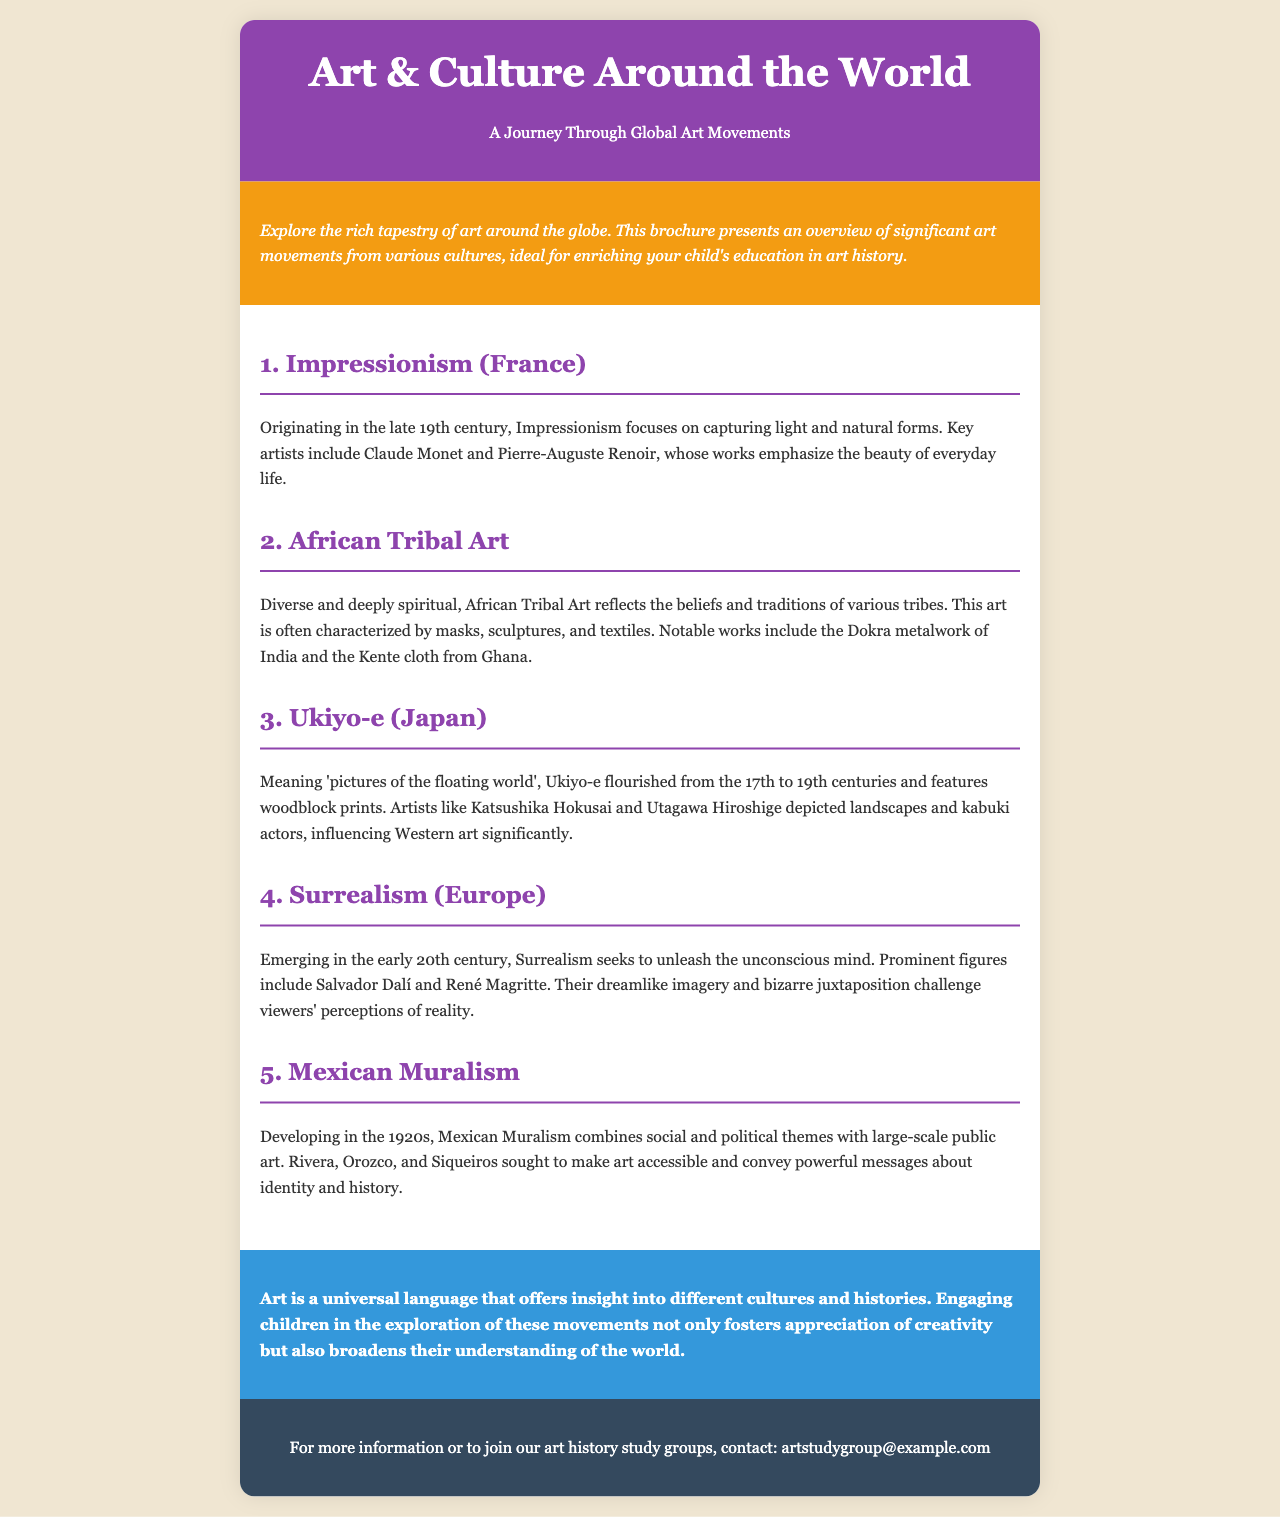What is the title of the brochure? The title of the brochure is found in the header section, stating the main theme.
Answer: Art & Culture Around the World Who is a key artist of Impressionism? This information is found in the description of the Impressionism section, highlighting notable figures.
Answer: Claude Monet Which art movement focuses on capturing light and natural forms? The statement regarding this movement is in the overview of one of the sections.
Answer: Impressionism What type of art is characterized by masks and textiles? This characteristic is specifically mentioned in the section discussing different art forms.
Answer: African Tribal Art In what century did Ukiyo-e flourish? The timeframe for Ukiyo-e's flourishing is mentioned within its specific section.
Answer: 17th to 19th centuries Who are three prominent Mexican muralists? This detail is highlighted in the description of the Mexican Muralism section, listing significant artists.
Answer: Rivera, Orozco, Siqueiros What is the main purpose of engaging children in exploring art movements? The conclusion discusses the broader benefits of this engagement for children's understanding.
Answer: Broaden understanding What color is used in the conclusion section? The specific background color for the conclusion is identified in the document structure description.
Answer: Blue What type of contact information is provided for more inquiries? This detail appears in the footer where additional engagement options are mentioned.
Answer: Email address 